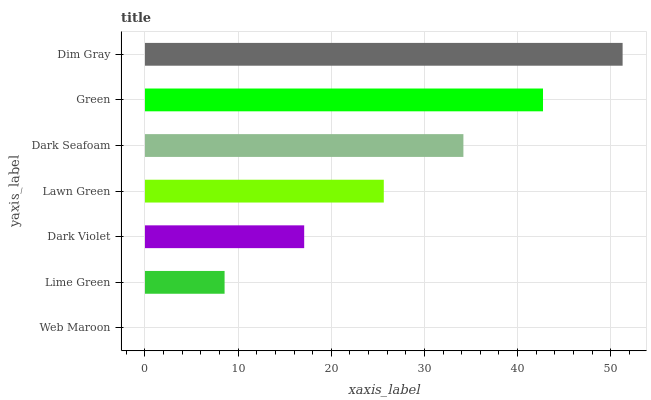Is Web Maroon the minimum?
Answer yes or no. Yes. Is Dim Gray the maximum?
Answer yes or no. Yes. Is Lime Green the minimum?
Answer yes or no. No. Is Lime Green the maximum?
Answer yes or no. No. Is Lime Green greater than Web Maroon?
Answer yes or no. Yes. Is Web Maroon less than Lime Green?
Answer yes or no. Yes. Is Web Maroon greater than Lime Green?
Answer yes or no. No. Is Lime Green less than Web Maroon?
Answer yes or no. No. Is Lawn Green the high median?
Answer yes or no. Yes. Is Lawn Green the low median?
Answer yes or no. Yes. Is Dim Gray the high median?
Answer yes or no. No. Is Dark Seafoam the low median?
Answer yes or no. No. 